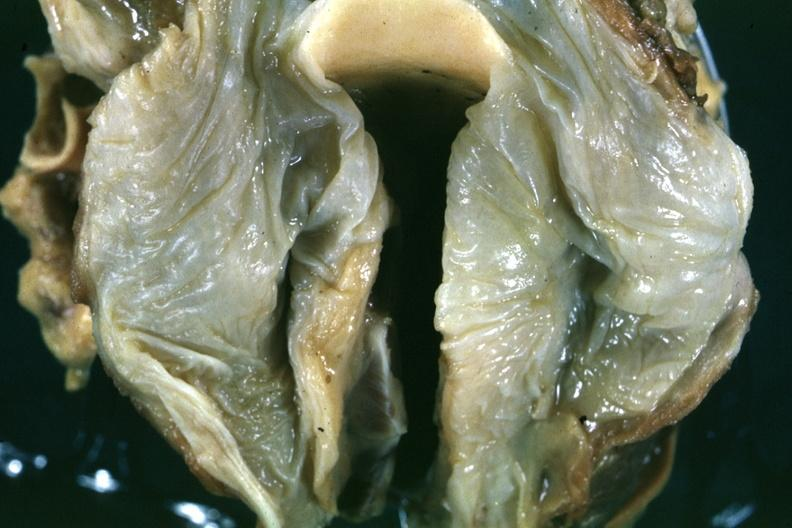where is this?
Answer the question using a single word or phrase. Oral 